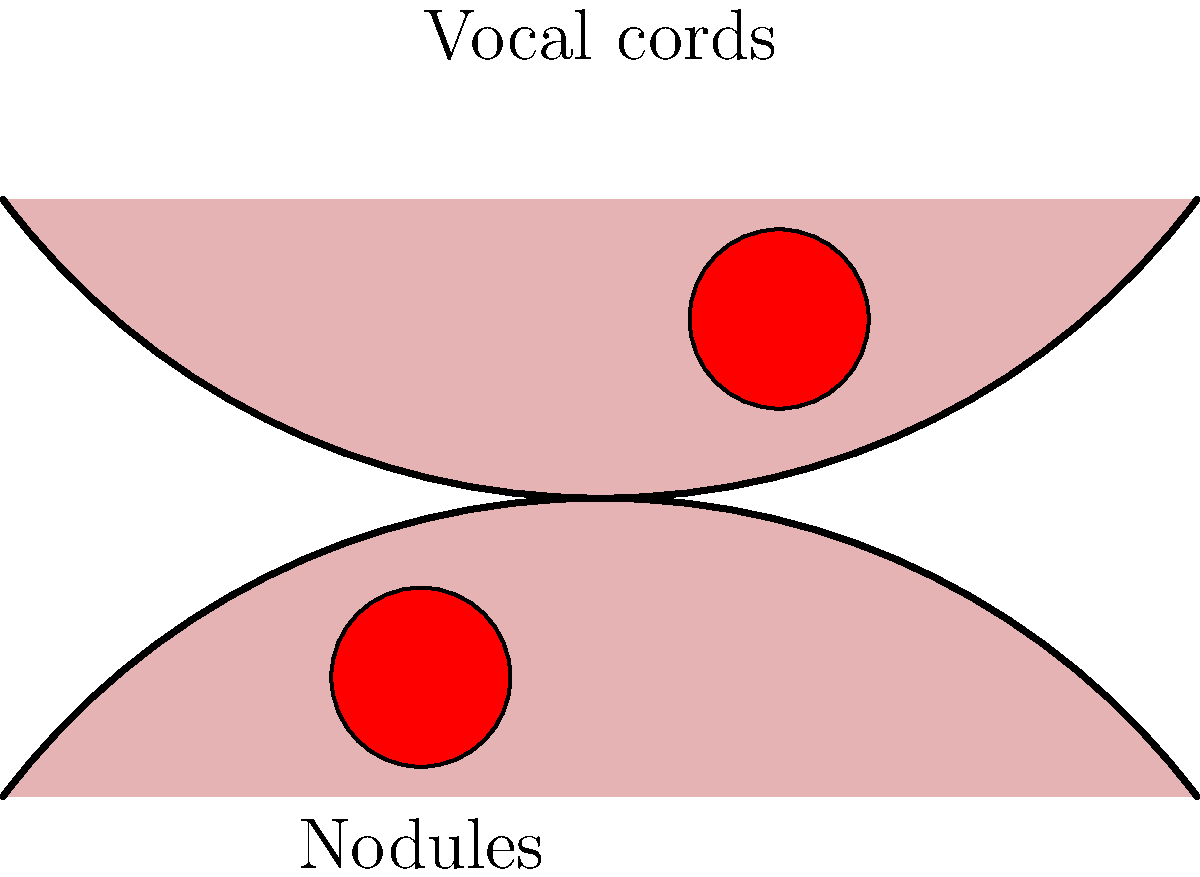Based on the endoscopic image of a child's larynx shown above, what is the most likely diagnosis, and what characteristic features support this diagnosis? To diagnose vocal cord nodules in children based on an endoscopic image of the larynx, we need to follow these steps:

1. Observe the overall appearance of the vocal cords:
   - The image shows two symmetrical structures representing the vocal cords.
   - The cords appear to be in a normal position during phonation (adducted).

2. Look for any abnormalities on the vocal cord surfaces:
   - There are two distinct, symmetrical lesions visible on the vocal cords.
   - These lesions appear as small, round, reddish masses on the free edges of both vocal cords.

3. Assess the location of the lesions:
   - The lesions are located at the junction of the anterior and middle thirds of the vocal cords.
   - This location is typical for vocal cord nodules, as it corresponds to the point of maximum mechanical stress during phonation.

4. Evaluate the symmetry of the lesions:
   - The lesions are bilaterally symmetrical, appearing on both vocal cords.
   - Symmetry is a characteristic feature of vocal cord nodules in children.

5. Consider the patient's age and history:
   - The question specifies that this is a pediatric case.
   - Vocal cord nodules are the most common cause of dysphonia in children.

6. Rule out other potential diagnoses:
   - The symmetrical, small, round appearance of the lesions is inconsistent with polyps (usually unilateral) or cysts (typically translucent).
   - The location and appearance do not suggest papillomatosis or other malignant conditions.

Based on these observations, the most likely diagnosis is bilateral vocal cord nodules. The characteristic features supporting this diagnosis are:
1. Symmetrical lesions
2. Location at the junction of anterior and middle thirds of vocal cords
3. Small, round, reddish appearance
4. Occurrence in a pediatric patient
Answer: Bilateral vocal cord nodules 